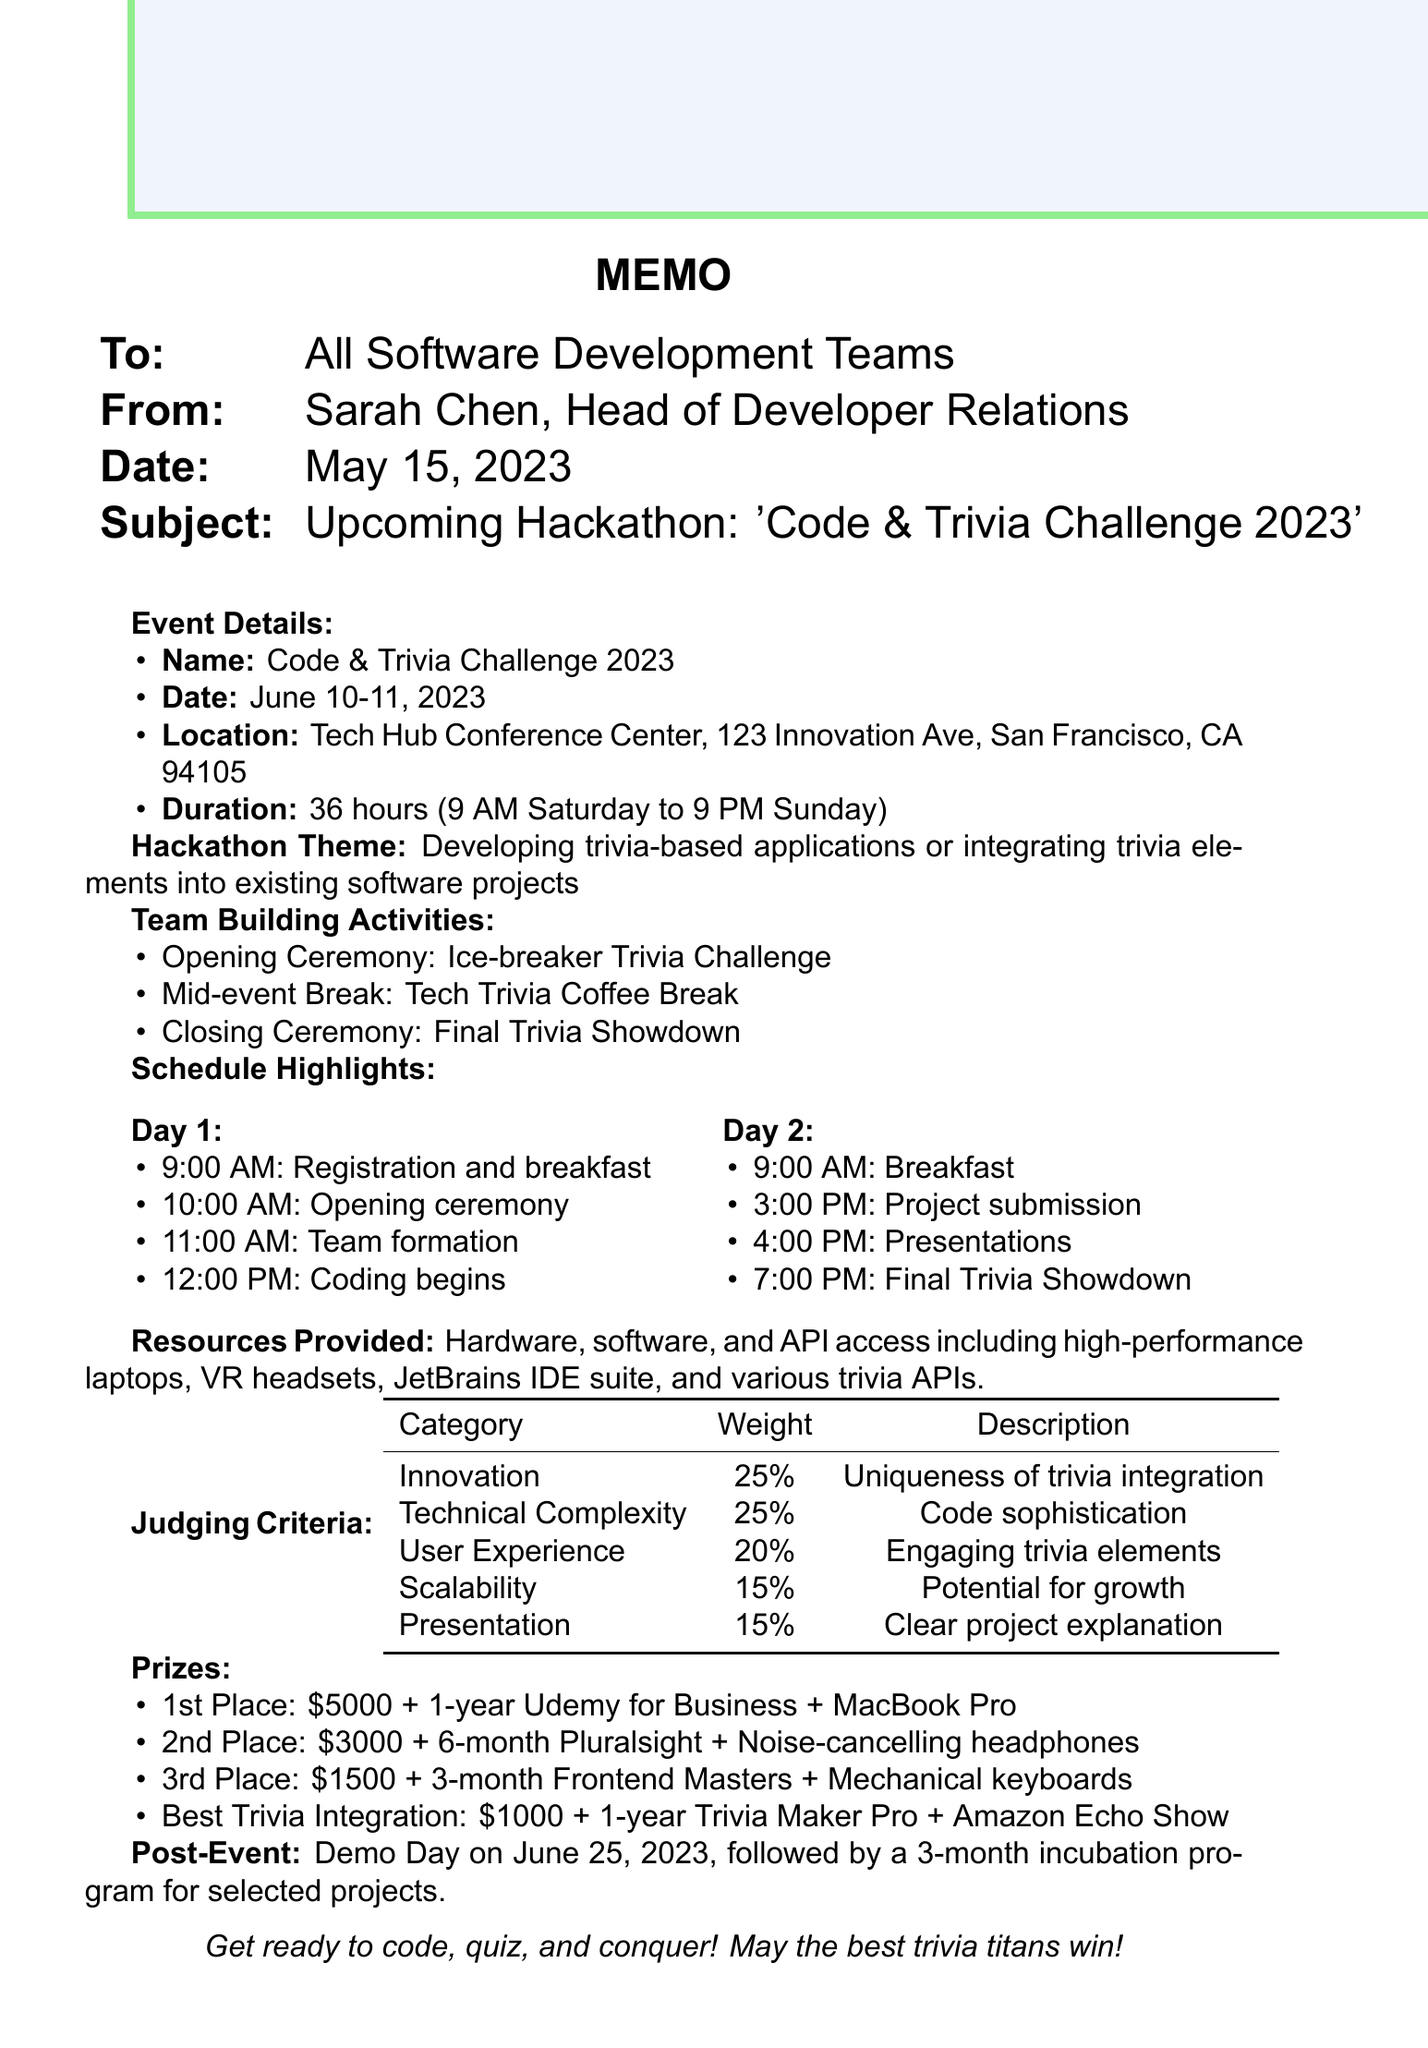what is the name of the hackathon? The name of the hackathon is specified in the document, which is 'Code & Trivia Challenge 2023'.
Answer: Code & Trivia Challenge 2023 when does the event start and end? The event starts on June 10, 2023, and ends on June 11, 2023.
Answer: June 10-11, 2023 how long is the hackathon? The document states that the duration of the hackathon is 36 hours.
Answer: 36 hours what is the prize for the first place team? The document lists various prizes, with the first place team receiving $5000 and additional perks.
Answer: $5000 which activity occurs during the mid-event break? The mid-event break includes a trivia session focused on technology and coding history.
Answer: Tech Trivia Coffee Break what is the purpose of the hackathon? The main focus of the hackathon is to develop trivia-based applications or integrate trivia elements into existing software projects.
Answer: Developing trivia-based applications how many categories are included in the judging criteria? The judging criteria includes several categories as outlined in the document, totaling five categories.
Answer: Five who is the sender of the memo? The sender of the memo is identified as Sarah Chen, Head of Developer Relations.
Answer: Sarah Chen what is the location of the event? The memo specifies the venue location for the hackathon event as the Tech Hub Conference Center in San Francisco.
Answer: Tech Hub Conference Center, San Francisco 